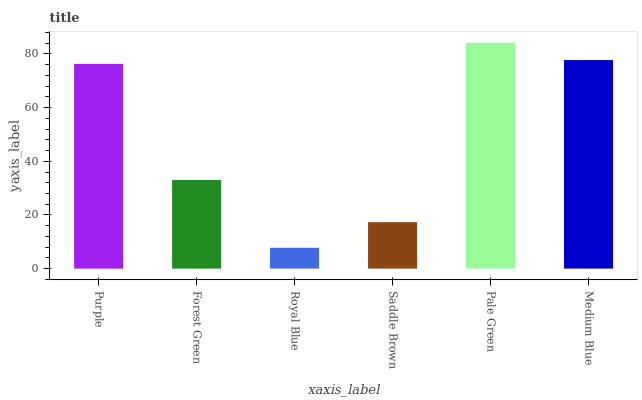Is Royal Blue the minimum?
Answer yes or no. Yes. Is Pale Green the maximum?
Answer yes or no. Yes. Is Forest Green the minimum?
Answer yes or no. No. Is Forest Green the maximum?
Answer yes or no. No. Is Purple greater than Forest Green?
Answer yes or no. Yes. Is Forest Green less than Purple?
Answer yes or no. Yes. Is Forest Green greater than Purple?
Answer yes or no. No. Is Purple less than Forest Green?
Answer yes or no. No. Is Purple the high median?
Answer yes or no. Yes. Is Forest Green the low median?
Answer yes or no. Yes. Is Medium Blue the high median?
Answer yes or no. No. Is Saddle Brown the low median?
Answer yes or no. No. 